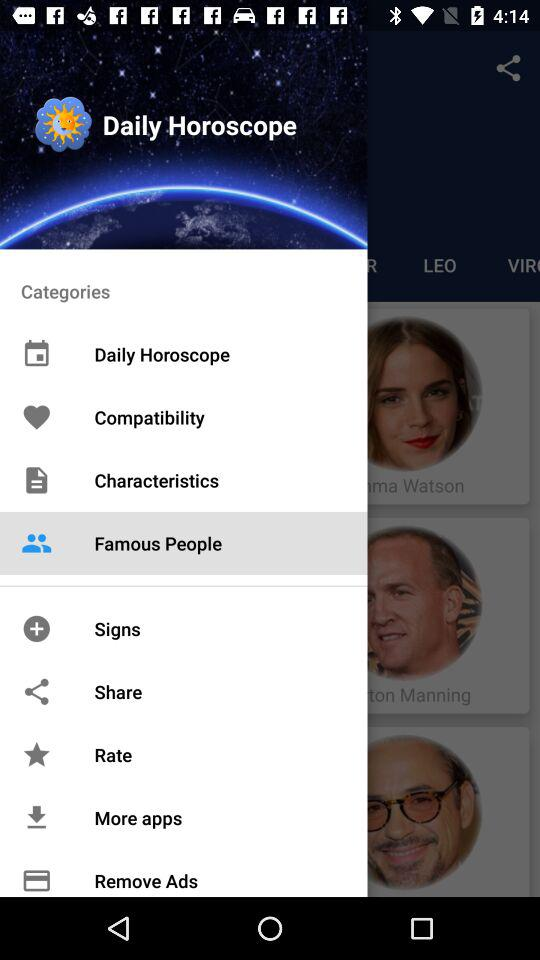Which items were selected there? The selected item was "Famous People". 